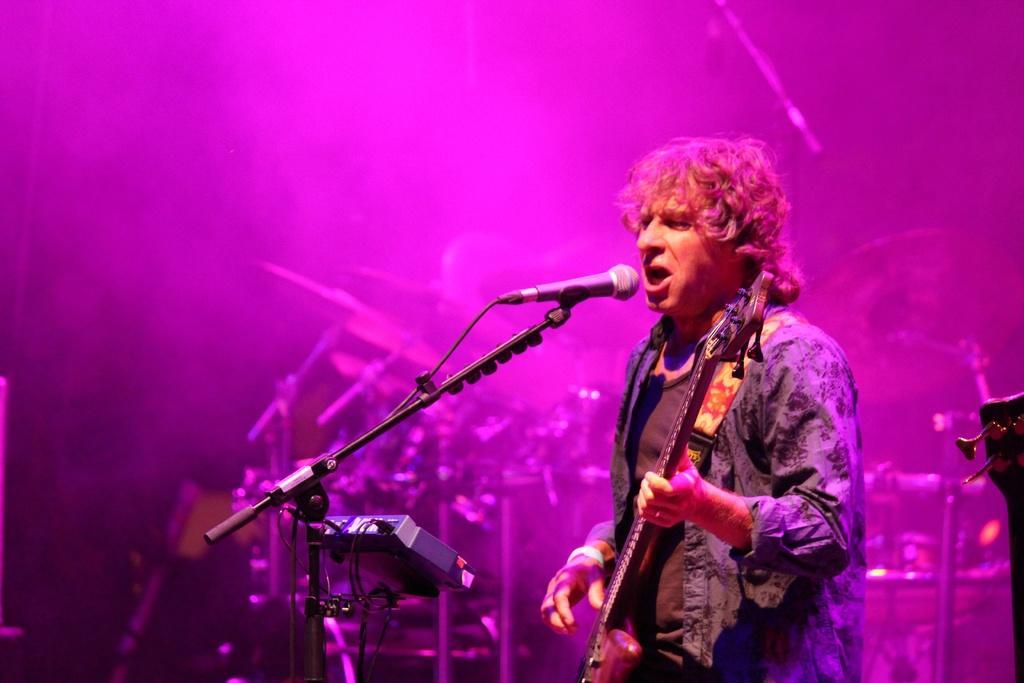Describe this image in one or two sentences. This man is playing guitar and singing in-front of mic. These are musical instruments. 